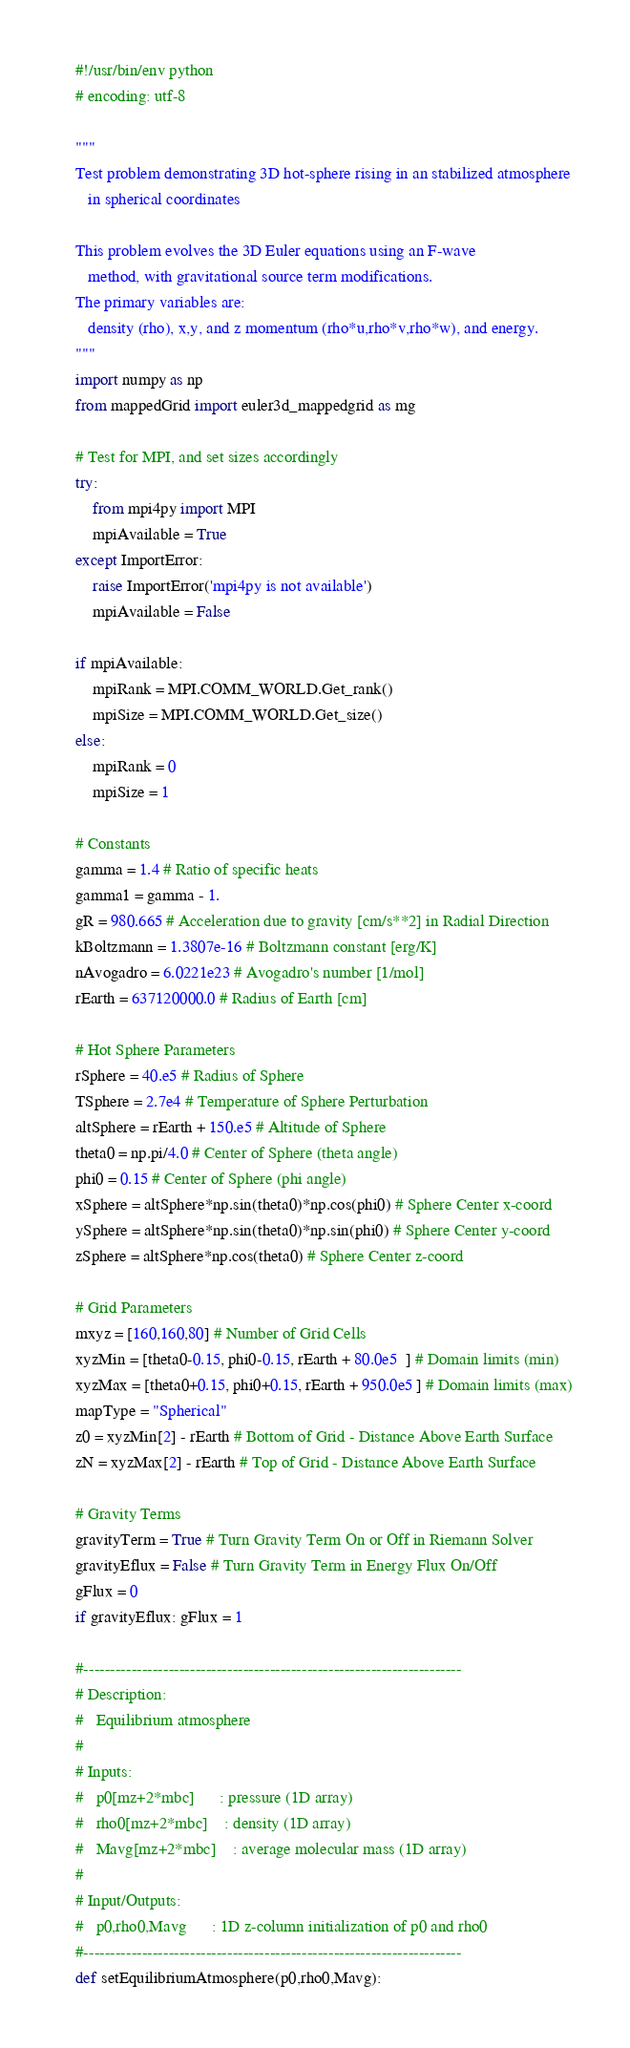Convert code to text. <code><loc_0><loc_0><loc_500><loc_500><_Python_>#!/usr/bin/env python
# encoding: utf-8

""" 
Test problem demonstrating 3D hot-sphere rising in an stabilized atmosphere
   in spherical coordinates

This problem evolves the 3D Euler equations using an F-wave
   method, with gravitational source term modifications.
The primary variables are: 
   density (rho), x,y, and z momentum (rho*u,rho*v,rho*w), and energy.
"""
import numpy as np
from mappedGrid import euler3d_mappedgrid as mg

# Test for MPI, and set sizes accordingly
try:
    from mpi4py import MPI
    mpiAvailable = True
except ImportError:
    raise ImportError('mpi4py is not available')
    mpiAvailable = False

if mpiAvailable:
    mpiRank = MPI.COMM_WORLD.Get_rank()
    mpiSize = MPI.COMM_WORLD.Get_size()
else:
    mpiRank = 0
    mpiSize = 1

# Constants
gamma = 1.4 # Ratio of specific heats
gamma1 = gamma - 1.
gR = 980.665 # Acceleration due to gravity [cm/s**2] in Radial Direction
kBoltzmann = 1.3807e-16 # Boltzmann constant [erg/K]
nAvogadro = 6.0221e23 # Avogadro's number [1/mol]
rEarth = 637120000.0 # Radius of Earth [cm]

# Hot Sphere Parameters
rSphere = 40.e5 # Radius of Sphere
TSphere = 2.7e4 # Temperature of Sphere Perturbation
altSphere = rEarth + 150.e5 # Altitude of Sphere
theta0 = np.pi/4.0 # Center of Sphere (theta angle)
phi0 = 0.15 # Center of Sphere (phi angle)
xSphere = altSphere*np.sin(theta0)*np.cos(phi0) # Sphere Center x-coord
ySphere = altSphere*np.sin(theta0)*np.sin(phi0) # Sphere Center y-coord
zSphere = altSphere*np.cos(theta0) # Sphere Center z-coord

# Grid Parameters
mxyz = [160,160,80] # Number of Grid Cells
xyzMin = [theta0-0.15, phi0-0.15, rEarth + 80.0e5  ] # Domain limits (min)
xyzMax = [theta0+0.15, phi0+0.15, rEarth + 950.0e5 ] # Domain limits (max)
mapType = "Spherical"
z0 = xyzMin[2] - rEarth # Bottom of Grid - Distance Above Earth Surface
zN = xyzMax[2] - rEarth # Top of Grid - Distance Above Earth Surface

# Gravity Terms
gravityTerm = True # Turn Gravity Term On or Off in Riemann Solver
gravityEflux = False # Turn Gravity Term in Energy Flux On/Off
gFlux = 0
if gravityEflux: gFlux = 1

#-----------------------------------------------------------------------
# Description:
#   Equilibrium atmosphere
#
# Inputs:
#   p0[mz+2*mbc]      : pressure (1D array)
#   rho0[mz+2*mbc]    : density (1D array)
#   Mavg[mz+2*mbc]    : average molecular mass (1D array)
# 
# Input/Outputs:
#   p0,rho0,Mavg      : 1D z-column initialization of p0 and rho0
#-----------------------------------------------------------------------
def setEquilibriumAtmosphere(p0,rho0,Mavg):
</code> 